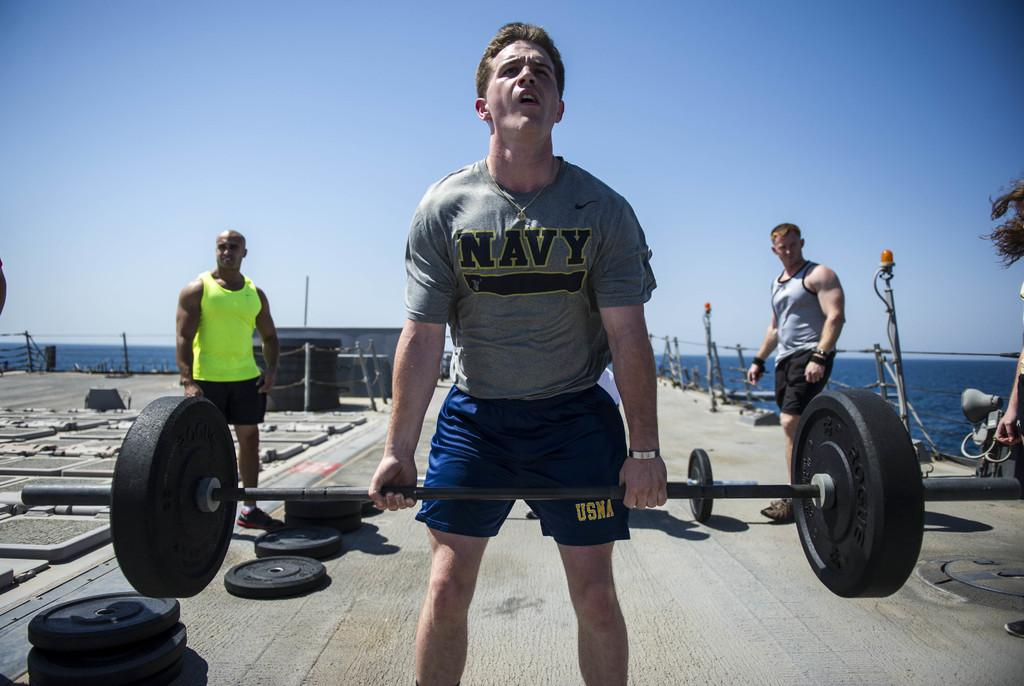<image>
Offer a succinct explanation of the picture presented. A man wearing a Navy tee shirt lifts a barbell outside. 